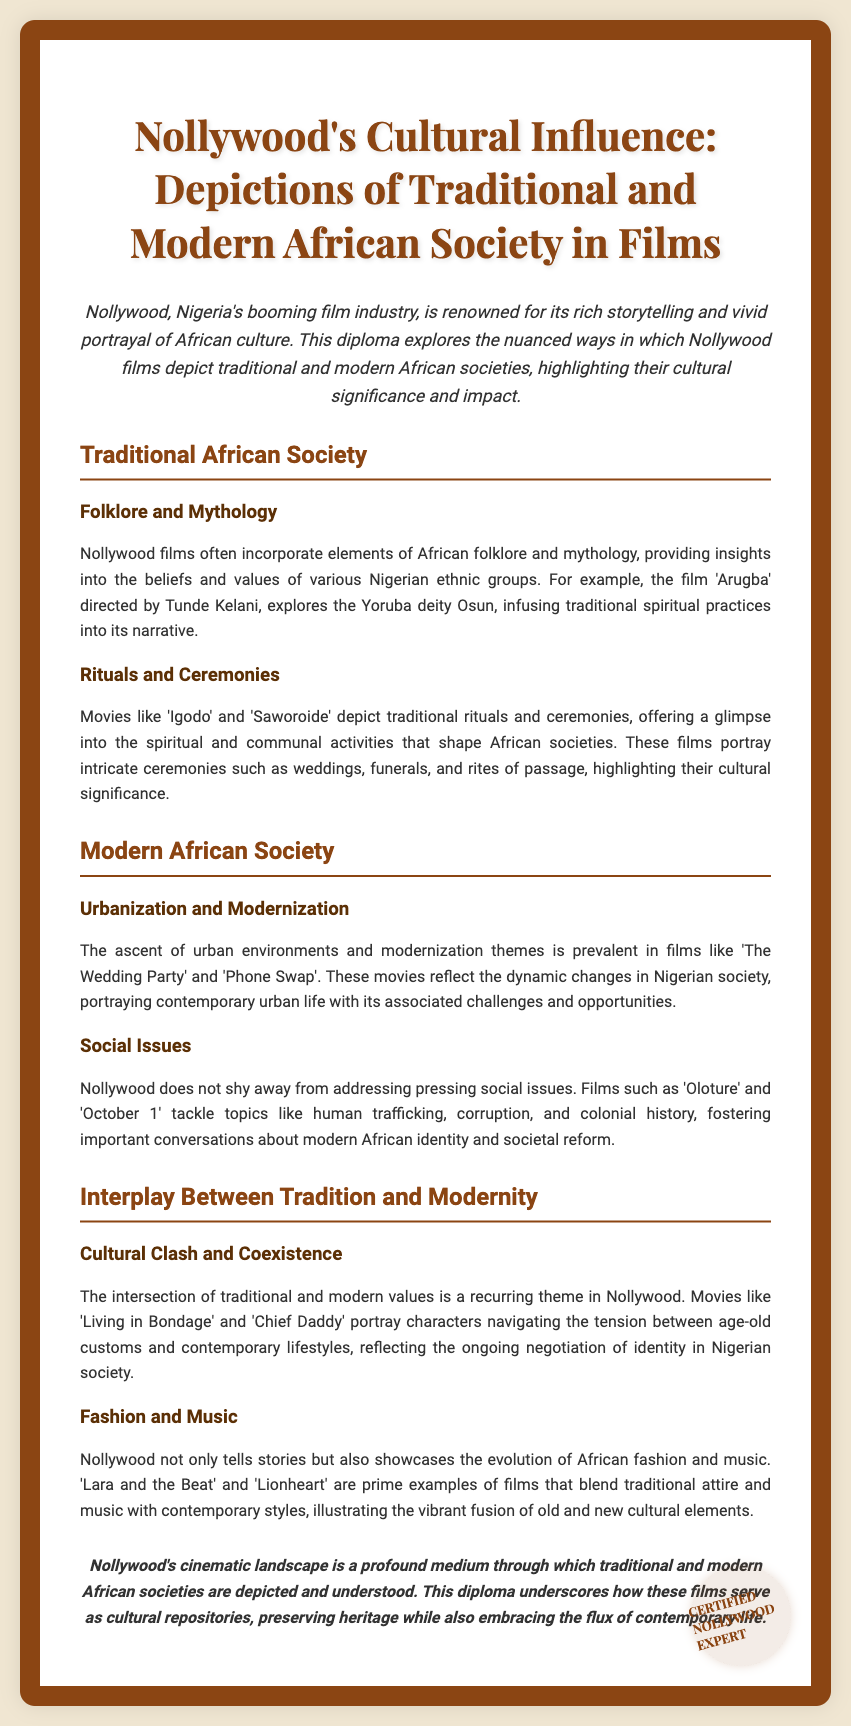What is the title of the diploma? The title of the diploma is presented prominently at the top of the document.
Answer: Nollywood's Cultural Influence: Depictions of Traditional and Modern African Society in Films Who directed the film 'Arugba'? The director of 'Arugba' is mentioned in the context of the film's exploration of Yoruba mythology.
Answer: Tunde Kelani Name a film that portrays traditional rituals and ceremonies. The document lists specific films that depict traditional ceremonies in African societies.
Answer: Igodo Which film addresses the issue of human trafficking? 'Oloture' is specifically mentioned as tackling this pressing social issue.
Answer: Oloture What is a recurring theme in Nollywood films according to the document? The document discusses themes that appear frequently in Nollywood narratives, especially concerning societal values.
Answer: Cultural Clash and Coexistence Name a film that blends traditional attire with contemporary styles. The document provides examples of films that showcase the fusion of old and new cultural elements.
Answer: Lara and the Beat What role does Nollywood play in depicting African societies? The conclusion of the document emphasizes Nollywood's importance in cultural representation and preservation.
Answer: Cultural repositories What are two examples of modern society themes in Nollywood films? Themes of urbanization and social issues are highlighted in the context of contemporary Nigerian life.
Answer: Urbanization and Social Issues 